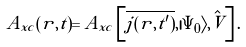<formula> <loc_0><loc_0><loc_500><loc_500>A _ { x c } ( r , t ) = A _ { x c } \left [ \overline { j ( r , t ^ { \prime } ) } , | \Psi _ { 0 } \rangle , \hat { V } \right ] .</formula> 